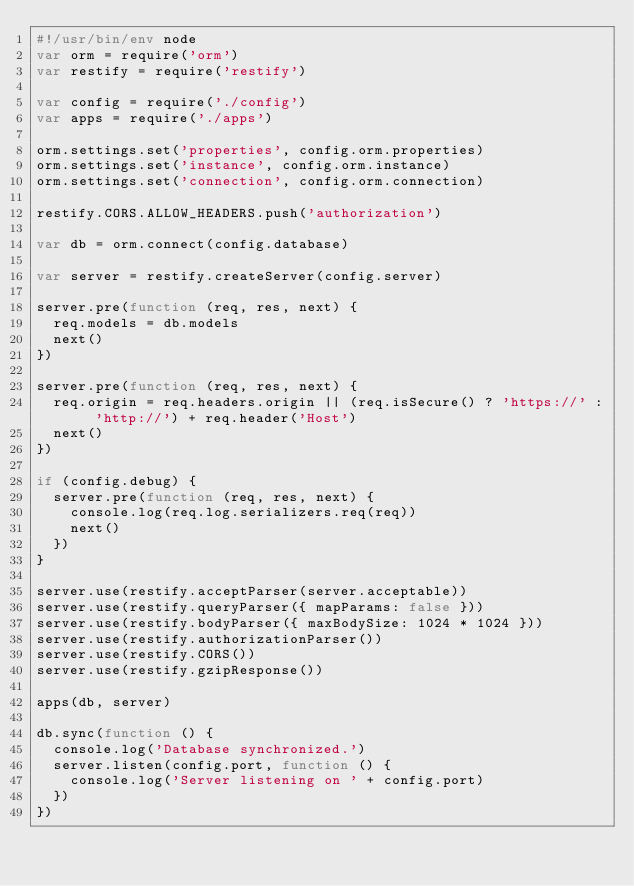<code> <loc_0><loc_0><loc_500><loc_500><_JavaScript_>#!/usr/bin/env node
var orm = require('orm')
var restify = require('restify')

var config = require('./config')
var apps = require('./apps')

orm.settings.set('properties', config.orm.properties)
orm.settings.set('instance', config.orm.instance)
orm.settings.set('connection', config.orm.connection)

restify.CORS.ALLOW_HEADERS.push('authorization')

var db = orm.connect(config.database)

var server = restify.createServer(config.server)

server.pre(function (req, res, next) {
  req.models = db.models
  next()
})

server.pre(function (req, res, next) {
  req.origin = req.headers.origin || (req.isSecure() ? 'https://' : 'http://') + req.header('Host')
  next()
})

if (config.debug) {
  server.pre(function (req, res, next) {
    console.log(req.log.serializers.req(req))
    next()
  })
}

server.use(restify.acceptParser(server.acceptable))
server.use(restify.queryParser({ mapParams: false }))
server.use(restify.bodyParser({ maxBodySize: 1024 * 1024 }))
server.use(restify.authorizationParser())
server.use(restify.CORS())
server.use(restify.gzipResponse())

apps(db, server)

db.sync(function () {
  console.log('Database synchronized.')
  server.listen(config.port, function () {
    console.log('Server listening on ' + config.port)
  })
})
</code> 